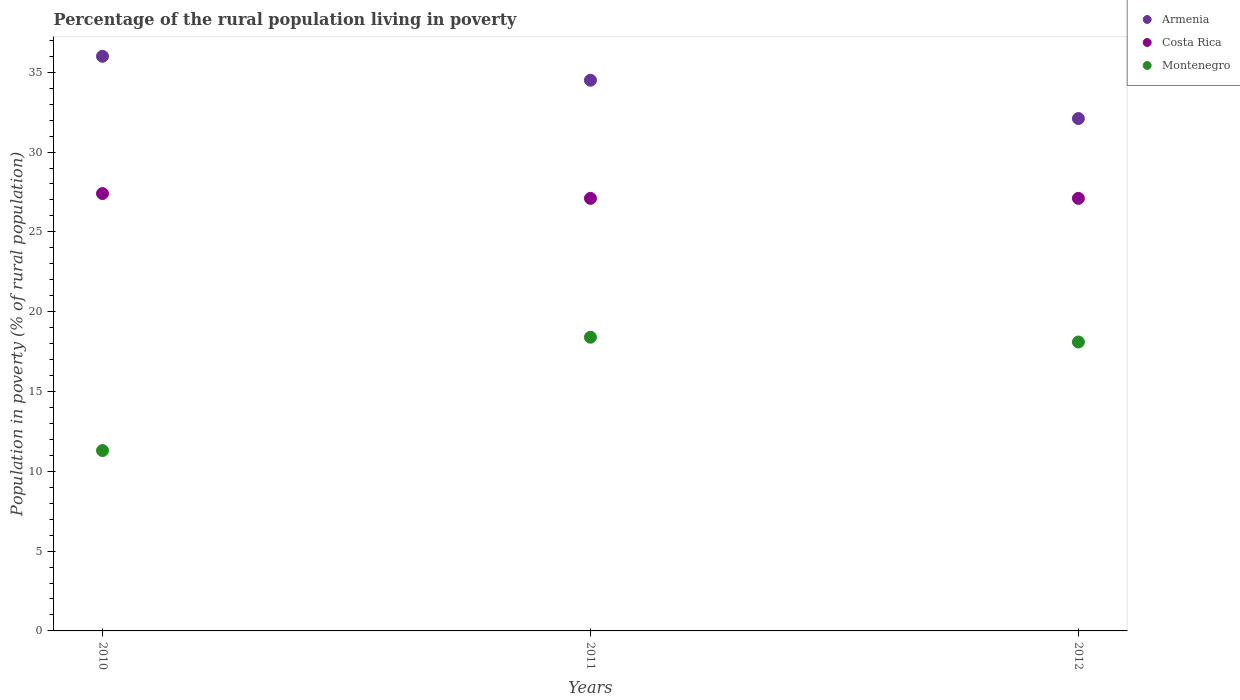How many different coloured dotlines are there?
Your response must be concise. 3. Is the number of dotlines equal to the number of legend labels?
Provide a short and direct response. Yes. Across all years, what is the maximum percentage of the rural population living in poverty in Costa Rica?
Offer a terse response. 27.4. Across all years, what is the minimum percentage of the rural population living in poverty in Costa Rica?
Keep it short and to the point. 27.1. What is the total percentage of the rural population living in poverty in Armenia in the graph?
Provide a succinct answer. 102.6. What is the difference between the percentage of the rural population living in poverty in Montenegro in 2010 and that in 2011?
Your response must be concise. -7.1. What is the difference between the percentage of the rural population living in poverty in Montenegro in 2011 and the percentage of the rural population living in poverty in Armenia in 2012?
Give a very brief answer. -13.7. What is the average percentage of the rural population living in poverty in Armenia per year?
Provide a short and direct response. 34.2. What is the ratio of the percentage of the rural population living in poverty in Armenia in 2011 to that in 2012?
Your response must be concise. 1.07. What is the difference between the highest and the second highest percentage of the rural population living in poverty in Montenegro?
Provide a succinct answer. 0.3. What is the difference between the highest and the lowest percentage of the rural population living in poverty in Montenegro?
Your answer should be very brief. 7.1. Is the sum of the percentage of the rural population living in poverty in Armenia in 2010 and 2011 greater than the maximum percentage of the rural population living in poverty in Costa Rica across all years?
Offer a terse response. Yes. Is it the case that in every year, the sum of the percentage of the rural population living in poverty in Armenia and percentage of the rural population living in poverty in Montenegro  is greater than the percentage of the rural population living in poverty in Costa Rica?
Offer a very short reply. Yes. Is the percentage of the rural population living in poverty in Montenegro strictly less than the percentage of the rural population living in poverty in Costa Rica over the years?
Provide a succinct answer. Yes. How many dotlines are there?
Ensure brevity in your answer.  3. What is the difference between two consecutive major ticks on the Y-axis?
Keep it short and to the point. 5. How many legend labels are there?
Offer a terse response. 3. How are the legend labels stacked?
Offer a very short reply. Vertical. What is the title of the graph?
Offer a very short reply. Percentage of the rural population living in poverty. Does "Cayman Islands" appear as one of the legend labels in the graph?
Offer a very short reply. No. What is the label or title of the Y-axis?
Provide a short and direct response. Population in poverty (% of rural population). What is the Population in poverty (% of rural population) in Armenia in 2010?
Offer a terse response. 36. What is the Population in poverty (% of rural population) of Costa Rica in 2010?
Give a very brief answer. 27.4. What is the Population in poverty (% of rural population) in Montenegro in 2010?
Your answer should be very brief. 11.3. What is the Population in poverty (% of rural population) of Armenia in 2011?
Offer a very short reply. 34.5. What is the Population in poverty (% of rural population) in Costa Rica in 2011?
Make the answer very short. 27.1. What is the Population in poverty (% of rural population) in Armenia in 2012?
Give a very brief answer. 32.1. What is the Population in poverty (% of rural population) in Costa Rica in 2012?
Make the answer very short. 27.1. Across all years, what is the maximum Population in poverty (% of rural population) in Armenia?
Make the answer very short. 36. Across all years, what is the maximum Population in poverty (% of rural population) of Costa Rica?
Provide a succinct answer. 27.4. Across all years, what is the minimum Population in poverty (% of rural population) in Armenia?
Make the answer very short. 32.1. Across all years, what is the minimum Population in poverty (% of rural population) in Costa Rica?
Provide a short and direct response. 27.1. What is the total Population in poverty (% of rural population) of Armenia in the graph?
Offer a terse response. 102.6. What is the total Population in poverty (% of rural population) of Costa Rica in the graph?
Ensure brevity in your answer.  81.6. What is the total Population in poverty (% of rural population) of Montenegro in the graph?
Provide a succinct answer. 47.8. What is the difference between the Population in poverty (% of rural population) in Costa Rica in 2010 and that in 2011?
Provide a succinct answer. 0.3. What is the difference between the Population in poverty (% of rural population) of Montenegro in 2010 and that in 2011?
Make the answer very short. -7.1. What is the difference between the Population in poverty (% of rural population) in Costa Rica in 2010 and that in 2012?
Ensure brevity in your answer.  0.3. What is the difference between the Population in poverty (% of rural population) in Montenegro in 2010 and that in 2012?
Your answer should be very brief. -6.8. What is the difference between the Population in poverty (% of rural population) of Costa Rica in 2011 and that in 2012?
Your response must be concise. 0. What is the difference between the Population in poverty (% of rural population) of Armenia in 2010 and the Population in poverty (% of rural population) of Costa Rica in 2011?
Keep it short and to the point. 8.9. What is the difference between the Population in poverty (% of rural population) of Costa Rica in 2010 and the Population in poverty (% of rural population) of Montenegro in 2011?
Ensure brevity in your answer.  9. What is the difference between the Population in poverty (% of rural population) of Armenia in 2010 and the Population in poverty (% of rural population) of Montenegro in 2012?
Your answer should be very brief. 17.9. What is the difference between the Population in poverty (% of rural population) of Armenia in 2011 and the Population in poverty (% of rural population) of Costa Rica in 2012?
Ensure brevity in your answer.  7.4. What is the average Population in poverty (% of rural population) of Armenia per year?
Keep it short and to the point. 34.2. What is the average Population in poverty (% of rural population) in Costa Rica per year?
Your response must be concise. 27.2. What is the average Population in poverty (% of rural population) in Montenegro per year?
Make the answer very short. 15.93. In the year 2010, what is the difference between the Population in poverty (% of rural population) of Armenia and Population in poverty (% of rural population) of Montenegro?
Keep it short and to the point. 24.7. In the year 2010, what is the difference between the Population in poverty (% of rural population) in Costa Rica and Population in poverty (% of rural population) in Montenegro?
Your answer should be compact. 16.1. In the year 2011, what is the difference between the Population in poverty (% of rural population) of Armenia and Population in poverty (% of rural population) of Costa Rica?
Keep it short and to the point. 7.4. In the year 2011, what is the difference between the Population in poverty (% of rural population) in Armenia and Population in poverty (% of rural population) in Montenegro?
Offer a very short reply. 16.1. What is the ratio of the Population in poverty (% of rural population) in Armenia in 2010 to that in 2011?
Give a very brief answer. 1.04. What is the ratio of the Population in poverty (% of rural population) of Costa Rica in 2010 to that in 2011?
Give a very brief answer. 1.01. What is the ratio of the Population in poverty (% of rural population) in Montenegro in 2010 to that in 2011?
Offer a terse response. 0.61. What is the ratio of the Population in poverty (% of rural population) of Armenia in 2010 to that in 2012?
Provide a succinct answer. 1.12. What is the ratio of the Population in poverty (% of rural population) in Costa Rica in 2010 to that in 2012?
Give a very brief answer. 1.01. What is the ratio of the Population in poverty (% of rural population) in Montenegro in 2010 to that in 2012?
Your answer should be very brief. 0.62. What is the ratio of the Population in poverty (% of rural population) in Armenia in 2011 to that in 2012?
Offer a terse response. 1.07. What is the ratio of the Population in poverty (% of rural population) in Montenegro in 2011 to that in 2012?
Offer a very short reply. 1.02. What is the difference between the highest and the second highest Population in poverty (% of rural population) in Costa Rica?
Offer a terse response. 0.3. What is the difference between the highest and the lowest Population in poverty (% of rural population) of Armenia?
Offer a very short reply. 3.9. 